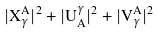Convert formula to latex. <formula><loc_0><loc_0><loc_500><loc_500>| X _ { \gamma } ^ { A } | ^ { 2 } + | U _ { A } ^ { \gamma } | ^ { 2 } + | V _ { \gamma } ^ { A } | ^ { 2 }</formula> 